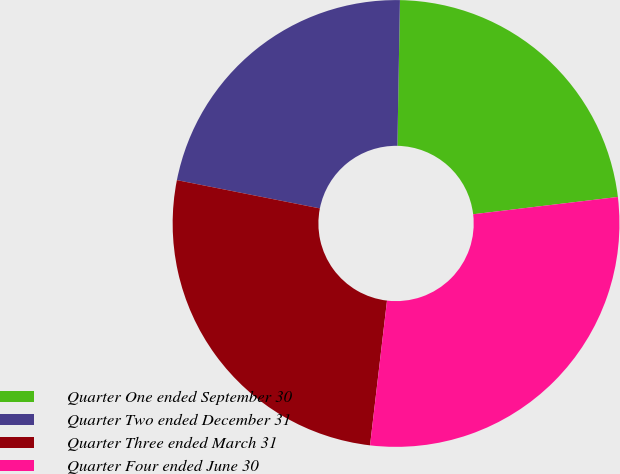<chart> <loc_0><loc_0><loc_500><loc_500><pie_chart><fcel>Quarter One ended September 30<fcel>Quarter Two ended December 31<fcel>Quarter Three ended March 31<fcel>Quarter Four ended June 30<nl><fcel>22.83%<fcel>22.17%<fcel>26.25%<fcel>28.75%<nl></chart> 